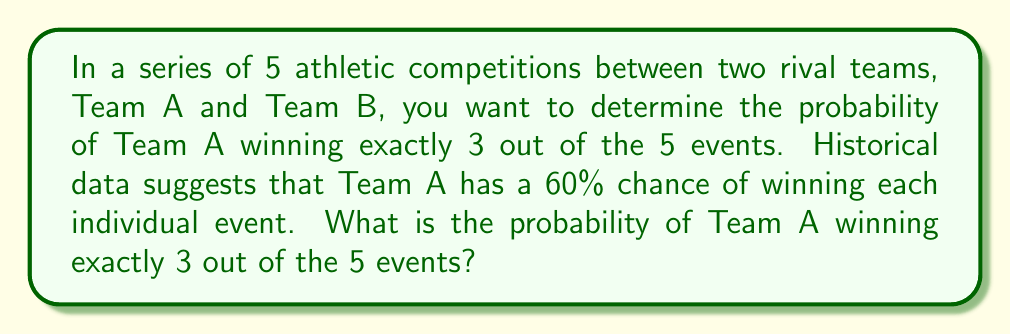Could you help me with this problem? To solve this problem, we'll use the binomial probability formula:

$$ P(X = k) = \binom{n}{k} p^k (1-p)^{n-k} $$

Where:
- $n$ is the number of trials (competitions)
- $k$ is the number of successes (wins for Team A)
- $p$ is the probability of success on each trial

Given:
- $n = 5$ (total number of competitions)
- $k = 3$ (number of wins we want for Team A)
- $p = 0.60$ (probability of Team A winning each event)

Step 1: Calculate the binomial coefficient $\binom{n}{k}$
$$ \binom{5}{3} = \frac{5!}{3!(5-3)!} = \frac{5 \cdot 4}{2 \cdot 1} = 10 $$

Step 2: Calculate $p^k$
$$ 0.60^3 = 0.216 $$

Step 3: Calculate $(1-p)^{n-k}$
$$ (1-0.60)^{5-3} = 0.40^2 = 0.16 $$

Step 4: Multiply all components
$$ P(X = 3) = 10 \cdot 0.216 \cdot 0.16 = 0.3456 $$

Therefore, the probability of Team A winning exactly 3 out of 5 events is 0.3456 or 34.56%.
Answer: 0.3456 